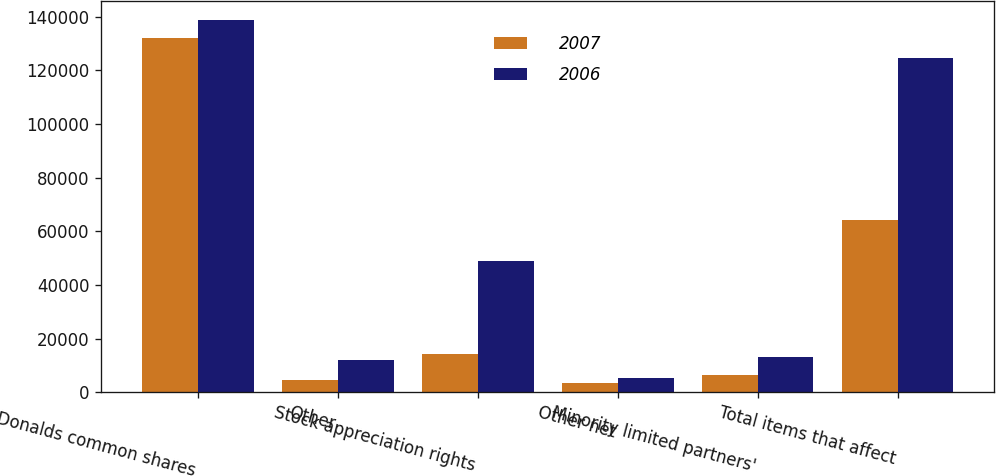Convert chart to OTSL. <chart><loc_0><loc_0><loc_500><loc_500><stacked_bar_chart><ecel><fcel>McDonalds common shares<fcel>Other<fcel>Stock appreciation rights<fcel>Other net<fcel>Minority limited partners'<fcel>Total items that affect<nl><fcel>2007<fcel>131911<fcel>4682<fcel>14280<fcel>3496<fcel>6297<fcel>64252<nl><fcel>2006<fcel>138815<fcel>12153<fcel>49043<fcel>5126<fcel>13204<fcel>124630<nl></chart> 